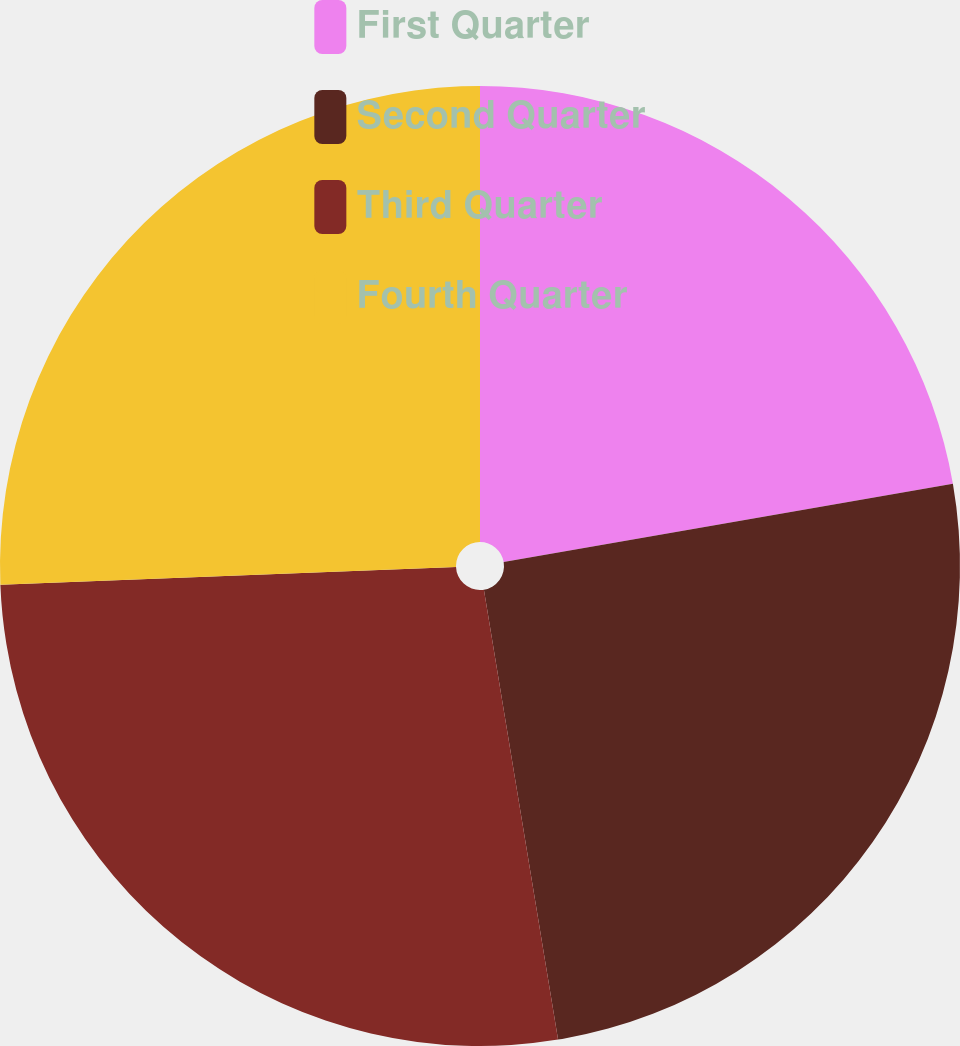Convert chart. <chart><loc_0><loc_0><loc_500><loc_500><pie_chart><fcel>First Quarter<fcel>Second Quarter<fcel>Third Quarter<fcel>Fourth Quarter<nl><fcel>22.26%<fcel>25.14%<fcel>26.98%<fcel>25.62%<nl></chart> 